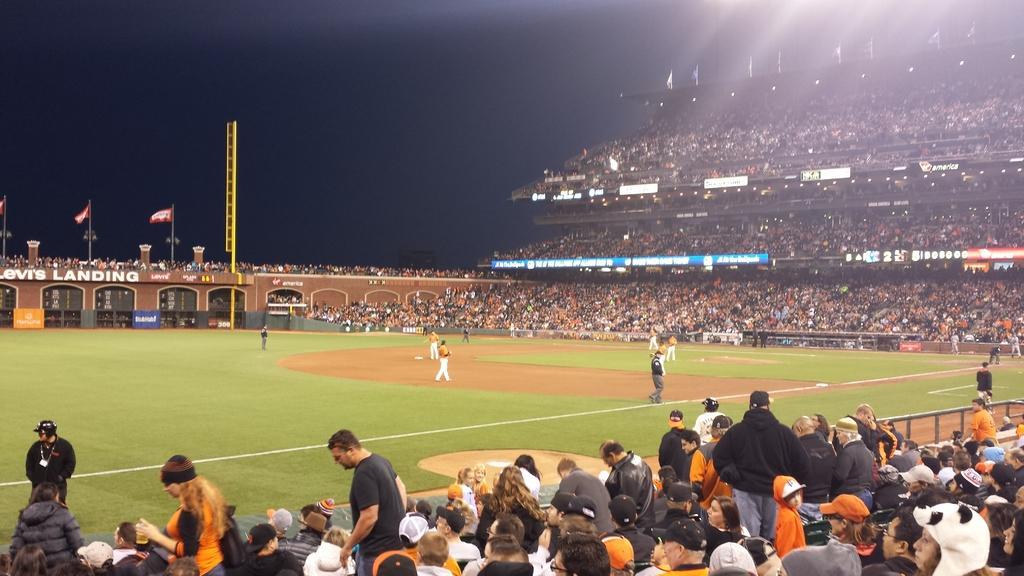Can you describe this image briefly? In this picture I can see a stadium and few people standing on the ground. I can see audience around, few flags and I can see sky. 